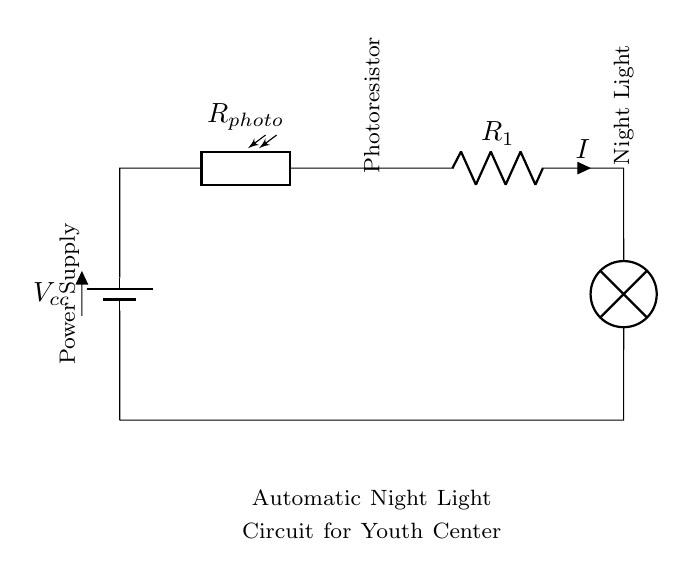What type of circuit is depicted in the diagram? The circuit is a series circuit, indicated by the sequential arrangement of components where the current flows through each component in a single path.
Answer: Series circuit What component detects light in this circuit? The component that detects light is the photoresistor, which changes its resistance based on the light intensity it receives.
Answer: Photoresistor What is the purpose of the first resistor labeled R1? The purpose of resistor R1 is to limit the current flowing to the lamp, which helps to prevent overheating and ensures proper operation of the night light.
Answer: Current limiter How many components are in this series circuit? There are three main components in this series circuit: the photoresistor, resistor R1, and the lamp, with the battery supplying the voltage.
Answer: Three What happens to the lamp when it's dark? When it's dark, the resistance of the photoresistor increases, allowing sufficient current to flow through R1 to turn on the lamp.
Answer: Lamp turns on What is the role of the power supply in this circuit? The role of the power supply is to provide the necessary voltage to drive the current through the circuit, enabling the components to function correctly.
Answer: Provide voltage How does changing light intensity affect this circuit? Changing light intensity affects the resistance of the photoresistor; more light decreases its resistance, reducing the current and potentially turning off the lamp, while less light increases resistance, allowing the lamp to turn on.
Answer: Changes current 